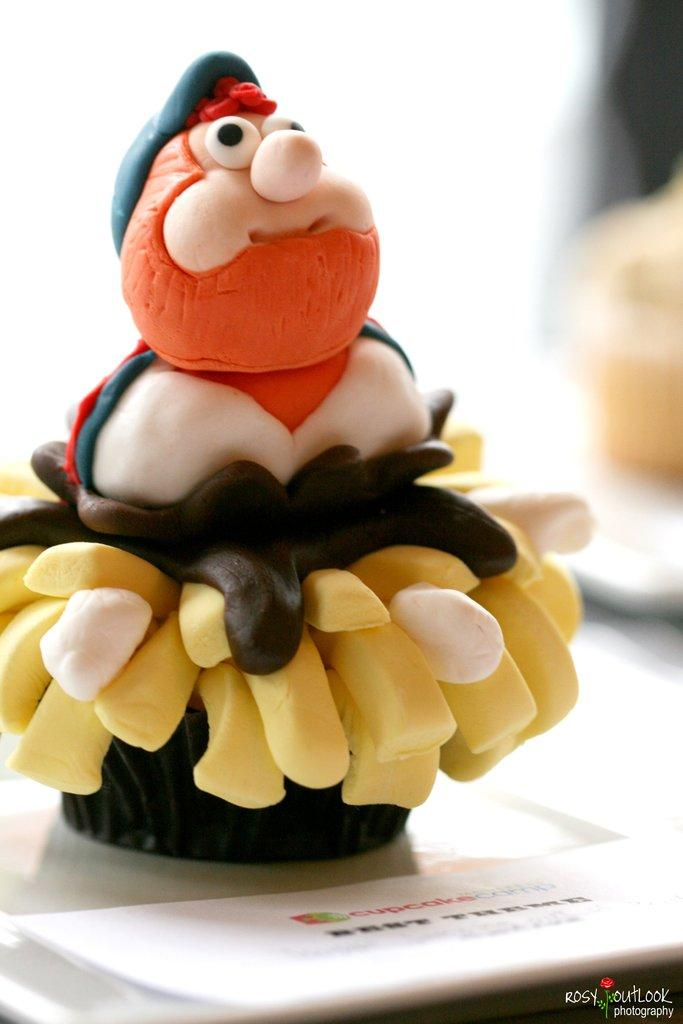What can be seen in the image besides the object the toy is placed on? There is text or writing in the right bottom corner of the image. What is the toy placed on? The toy is placed on an object. What type of object is the toy placed on? The provided facts do not specify the type of object the toy is placed on. Can you hear the whistle in the image? There is no whistle present in the image. What type of muscle is visible in the image in the image? There is no muscle visible in the image. 